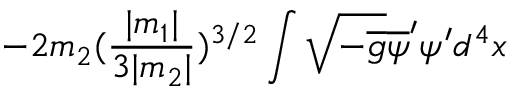<formula> <loc_0><loc_0><loc_500><loc_500>- 2 m _ { 2 } ( \frac { | m _ { 1 } | } { 3 | m _ { 2 } | } ) ^ { 3 / 2 } \int \sqrt { - \overline { g } } \overline { \psi } ^ { \prime } \psi ^ { \prime } d ^ { 4 } x</formula> 